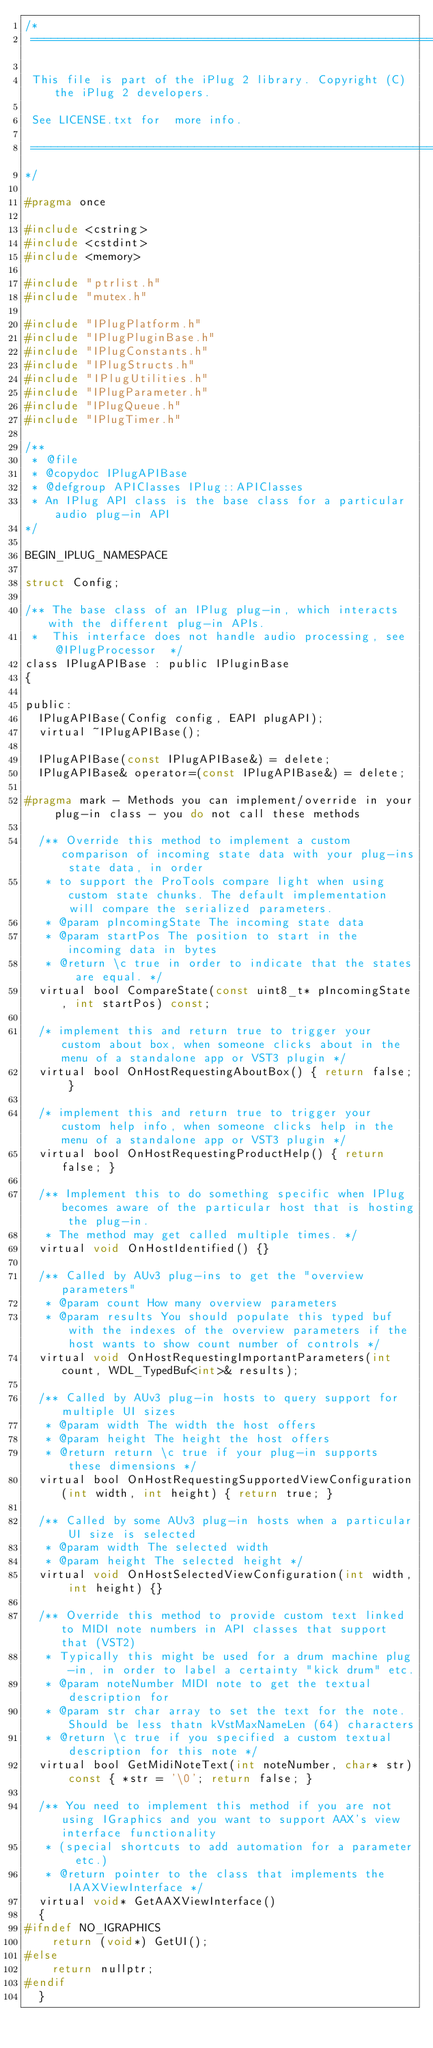<code> <loc_0><loc_0><loc_500><loc_500><_C_>/*
 ==============================================================================
 
 This file is part of the iPlug 2 library. Copyright (C) the iPlug 2 developers. 
 
 See LICENSE.txt for  more info.
 
 ==============================================================================
*/

#pragma once

#include <cstring>
#include <cstdint>
#include <memory>

#include "ptrlist.h"
#include "mutex.h"

#include "IPlugPlatform.h"
#include "IPlugPluginBase.h"
#include "IPlugConstants.h"
#include "IPlugStructs.h"
#include "IPlugUtilities.h"
#include "IPlugParameter.h"
#include "IPlugQueue.h"
#include "IPlugTimer.h"

/**
 * @file
 * @copydoc IPlugAPIBase
 * @defgroup APIClasses IPlug::APIClasses
 * An IPlug API class is the base class for a particular audio plug-in API
*/

BEGIN_IPLUG_NAMESPACE

struct Config;

/** The base class of an IPlug plug-in, which interacts with the different plug-in APIs.
 *  This interface does not handle audio processing, see @IPlugProcessor  */
class IPlugAPIBase : public IPluginBase
{

public:
  IPlugAPIBase(Config config, EAPI plugAPI);
  virtual ~IPlugAPIBase();
  
  IPlugAPIBase(const IPlugAPIBase&) = delete;
  IPlugAPIBase& operator=(const IPlugAPIBase&) = delete;
  
#pragma mark - Methods you can implement/override in your plug-in class - you do not call these methods

  /** Override this method to implement a custom comparison of incoming state data with your plug-ins state data, in order
   * to support the ProTools compare light when using custom state chunks. The default implementation will compare the serialized parameters.
   * @param pIncomingState The incoming state data
   * @param startPos The position to start in the incoming data in bytes
   * @return \c true in order to indicate that the states are equal. */
  virtual bool CompareState(const uint8_t* pIncomingState, int startPos) const;

  /* implement this and return true to trigger your custom about box, when someone clicks about in the menu of a standalone app or VST3 plugin */
  virtual bool OnHostRequestingAboutBox() { return false; }

  /* implement this and return true to trigger your custom help info, when someone clicks help in the menu of a standalone app or VST3 plugin */
  virtual bool OnHostRequestingProductHelp() { return false; }
  
  /** Implement this to do something specific when IPlug becomes aware of the particular host that is hosting the plug-in.
   * The method may get called multiple times. */
  virtual void OnHostIdentified() {}
  
  /** Called by AUv3 plug-ins to get the "overview parameters"
   * @param count How many overview parameters
   * @param results You should populate this typed buf with the indexes of the overview parameters if the host wants to show count number of controls */
  virtual void OnHostRequestingImportantParameters(int count, WDL_TypedBuf<int>& results);
  
  /** Called by AUv3 plug-in hosts to query support for multiple UI sizes
   * @param width The width the host offers
   * @param height The height the host offers
   * @return return \c true if your plug-in supports these dimensions */
  virtual bool OnHostRequestingSupportedViewConfiguration(int width, int height) { return true; }
  
  /** Called by some AUv3 plug-in hosts when a particular UI size is selected
   * @param width The selected width
   * @param height The selected height */
  virtual void OnHostSelectedViewConfiguration(int width, int height) {}

  /** Override this method to provide custom text linked to MIDI note numbers in API classes that support that (VST2)
   * Typically this might be used for a drum machine plug-in, in order to label a certainty "kick drum" etc.
   * @param noteNumber MIDI note to get the textual description for
   * @param str char array to set the text for the note. Should be less thatn kVstMaxNameLen (64) characters
   * @return \c true if you specified a custom textual description for this note */
  virtual bool GetMidiNoteText(int noteNumber, char* str) const { *str = '\0'; return false; }

  /** You need to implement this method if you are not using IGraphics and you want to support AAX's view interface functionality
   * (special shortcuts to add automation for a parameter etc.)
   * @return pointer to the class that implements the IAAXViewInterface */
  virtual void* GetAAXViewInterface()
  {
#ifndef NO_IGRAPHICS
    return (void*) GetUI();
#else
    return nullptr;
#endif
  }
</code> 